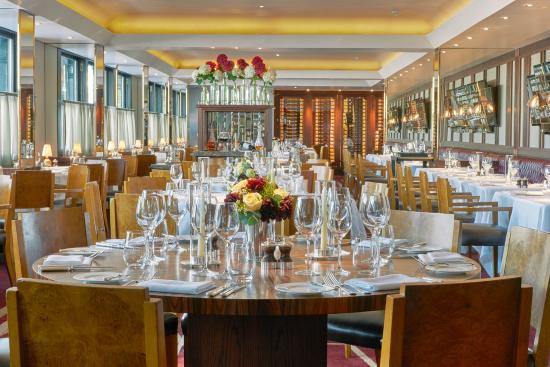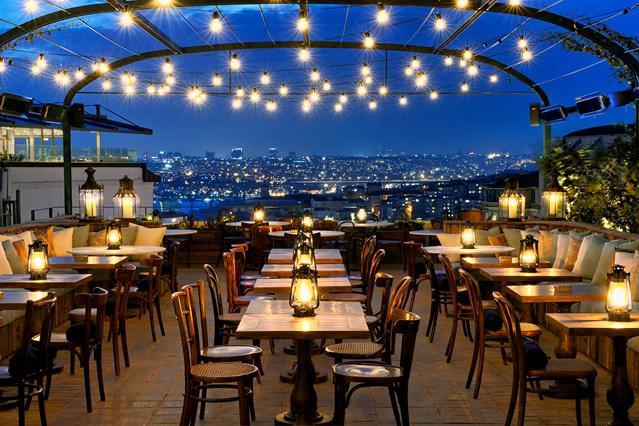The first image is the image on the left, the second image is the image on the right. Given the left and right images, does the statement "The right image shows an open-air rooftop dining area with a background of a span bridge featuring two square columns with castle-like tops." hold true? Answer yes or no. No. The first image is the image on the left, the second image is the image on the right. Assess this claim about the two images: "One image shows indoor seating at a restaurant and the other shows outdoor seating.". Correct or not? Answer yes or no. Yes. 